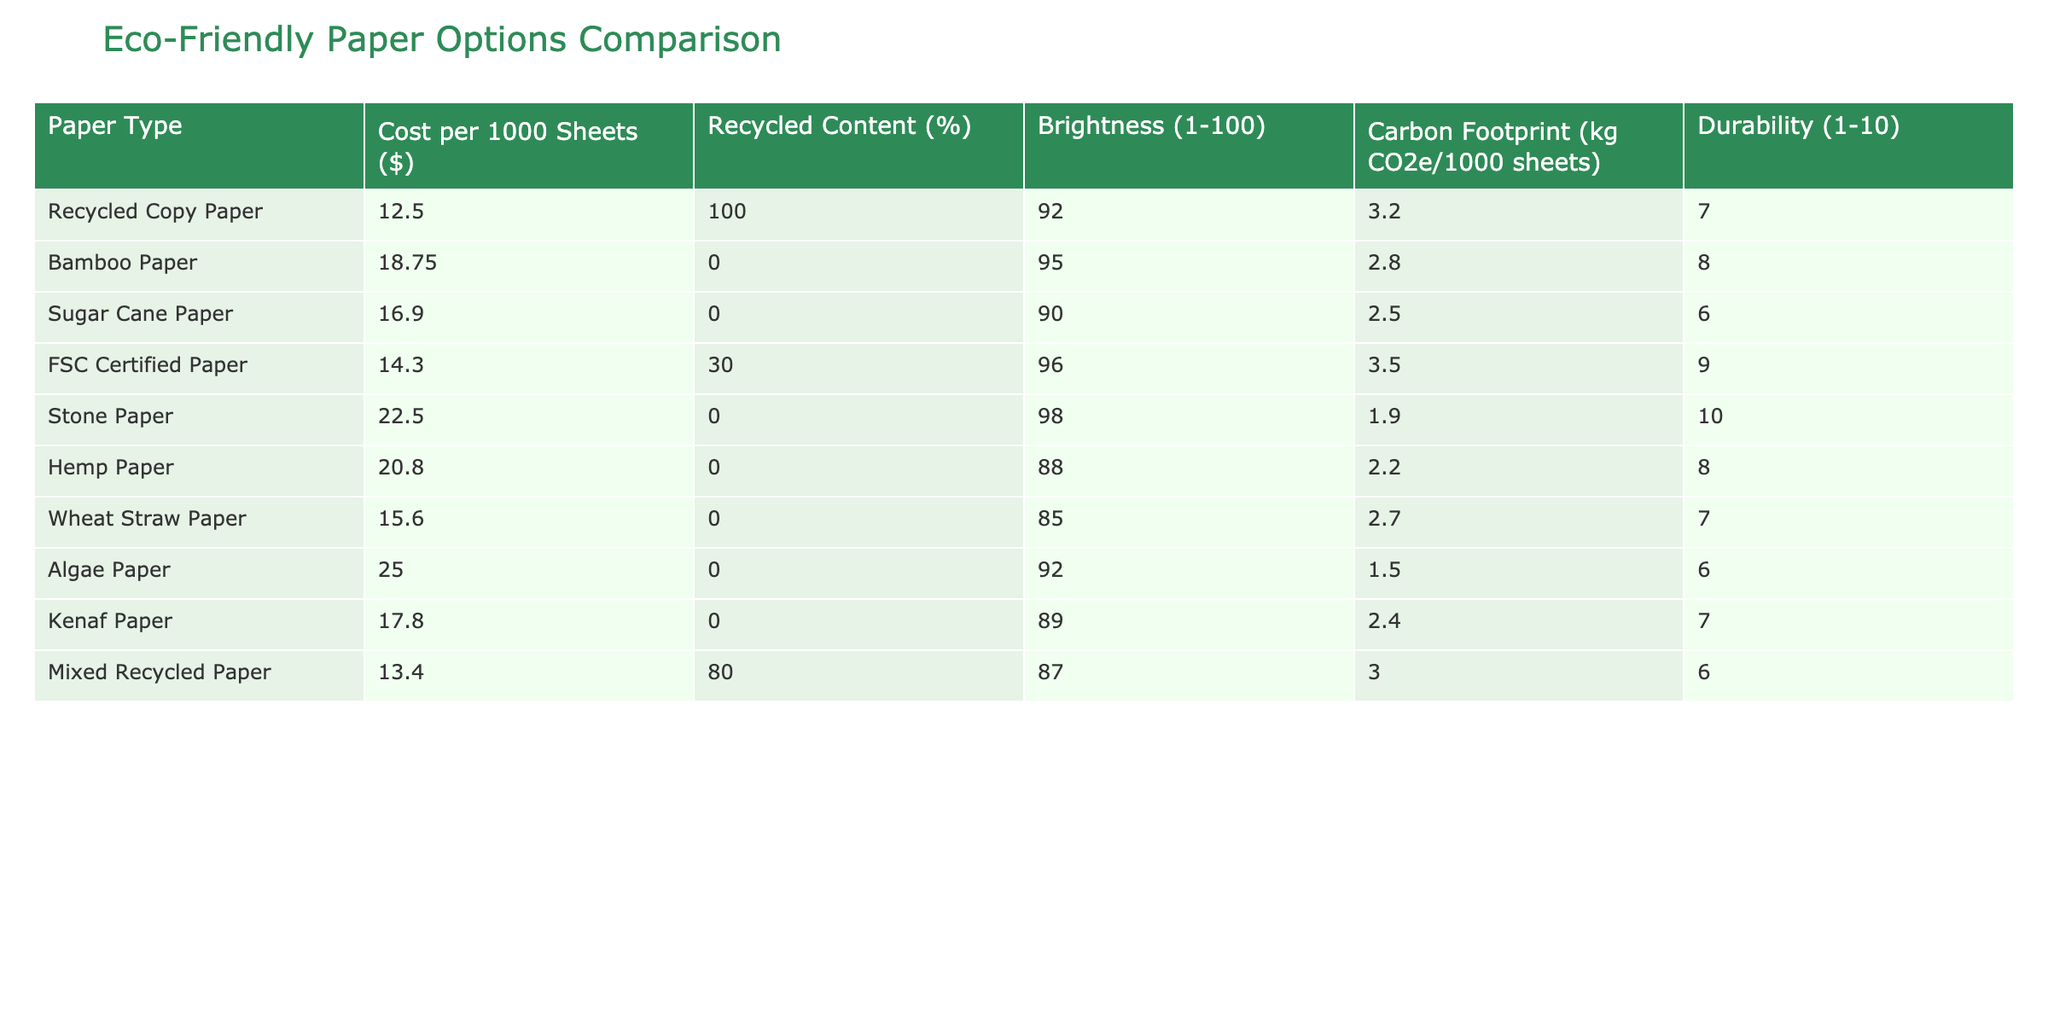What is the cost of Recycled Copy Paper for 1000 sheets? The table lists the cost of Recycled Copy Paper as $12.50 for 1000 sheets.
Answer: $12.50 Which paper type has the highest recycled content? The highest recycled content in the table is 100% for Recycled Copy Paper.
Answer: Recycled Copy Paper What is the brightness of Stone Paper? The table indicates that Stone Paper has a brightness level of 98.
Answer: 98 How does the carbon footprint of Bamboo Paper compare to that of Sugar Cane Paper? Bamboo Paper has a carbon footprint of 2.8 kg CO2e while Sugar Cane Paper has 2.5 kg CO2e; therefore, Bamboo Paper has a higher carbon footprint by 0.3 kg.
Answer: Bamboo Paper has a higher carbon footprint by 0.3 kg What is the average cost of all the paper types listed? To find the average cost, sum all costs: 12.50 + 18.75 + 16.90 + 14.30 + 22.50 + 20.80 + 15.60 + 25.00 + 17.80 + 13.40 =  175.55. Then divide by the number of paper types (10): 175.55 / 10 = 17.555, which rounds to 17.56.
Answer: $17.56 Which paper type has the highest durability rating? The highest durability rating in the table is 10 for Stone Paper.
Answer: Stone Paper Is there any paper type with zero recycled content that is also eco-friendly? Yes, both Bamboo Paper and Sugar Cane Paper have 0% recycled content, but they are considered eco-friendly.
Answer: Yes Which paper types have a carbon footprint lower than 2.5 kg CO2e? The only paper types with a carbon footprint lower than 2.5 kg CO2e are Stone Paper (1.9 kg CO2e) and Algae Paper (1.5 kg CO2e).
Answer: Stone Paper and Algae Paper What is the difference in brightness between the most eco-friendly (highest recycled content) and the least eco-friendly (0% recycled content) paper types? The brightness of Recycled Copy Paper (100% recycled content) is 92, and the brightness of Bamboo Paper (0% recycled content) is 95. The difference is 95 - 92 = 3.
Answer: 3 Are there more paper types with a recycled content above 50% or below 50%? There are five paper types with recycled content above 50% (Recycled Copy Paper, Mixed Recycled Paper) and five below (Bamboo, Sugar Cane, Stone, Hemp, Wheat Straw, Kenaf, Algae Paper), revealing equal counts.
Answer: Equal If you only consider papers with a cost below $15, how many options do you have? The papers costing less than $15 are Recycled Copy Paper ($12.50) and Mixed Recycled Paper ($13.40). Therefore, there are 2 options.
Answer: 2 